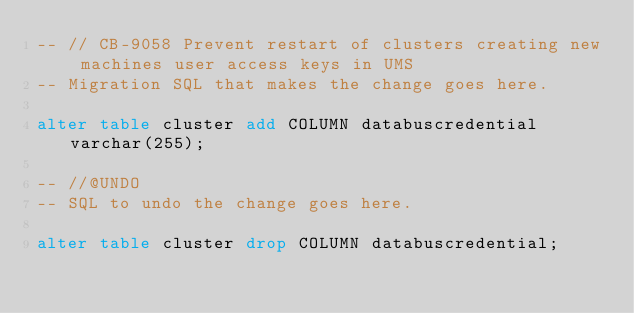<code> <loc_0><loc_0><loc_500><loc_500><_SQL_>-- // CB-9058 Prevent restart of clusters creating new machines user access keys in UMS
-- Migration SQL that makes the change goes here.

alter table cluster add COLUMN databuscredential varchar(255);

-- //@UNDO
-- SQL to undo the change goes here.

alter table cluster drop COLUMN databuscredential;</code> 